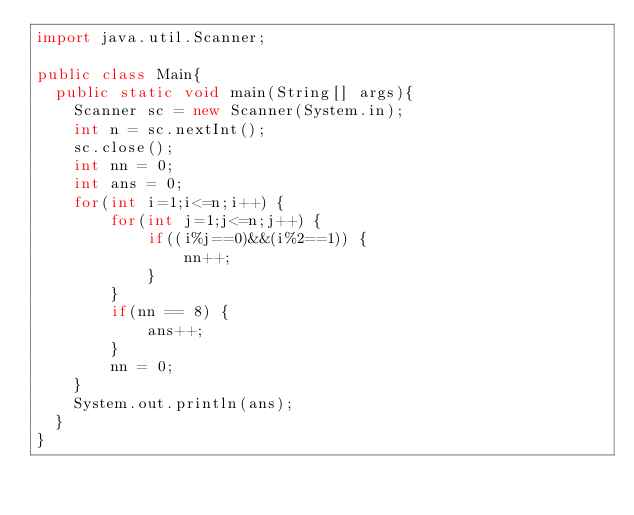Convert code to text. <code><loc_0><loc_0><loc_500><loc_500><_Java_>import java.util.Scanner;

public class Main{
  public static void main(String[] args){
    Scanner sc = new Scanner(System.in);
    int n = sc.nextInt();
    sc.close();
    int nn = 0;
    int ans = 0;
    for(int i=1;i<=n;i++) {
    	for(int j=1;j<=n;j++) {
    		if((i%j==0)&&(i%2==1)) {
    			nn++;
    		}
    	}
    	if(nn == 8) {
    		ans++;
    	}
    	nn = 0;
    }
    System.out.println(ans);
  }
}</code> 